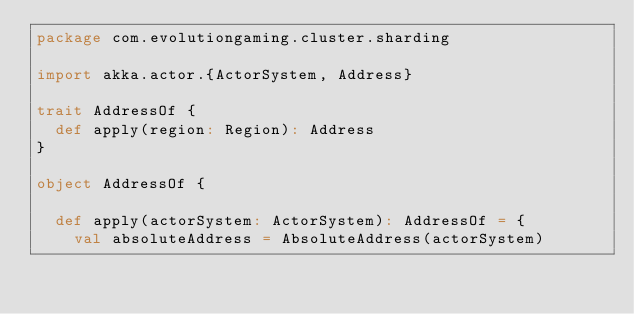<code> <loc_0><loc_0><loc_500><loc_500><_Scala_>package com.evolutiongaming.cluster.sharding

import akka.actor.{ActorSystem, Address}

trait AddressOf {
  def apply(region: Region): Address
}

object AddressOf {

  def apply(actorSystem: ActorSystem): AddressOf = {
    val absoluteAddress = AbsoluteAddress(actorSystem)</code> 